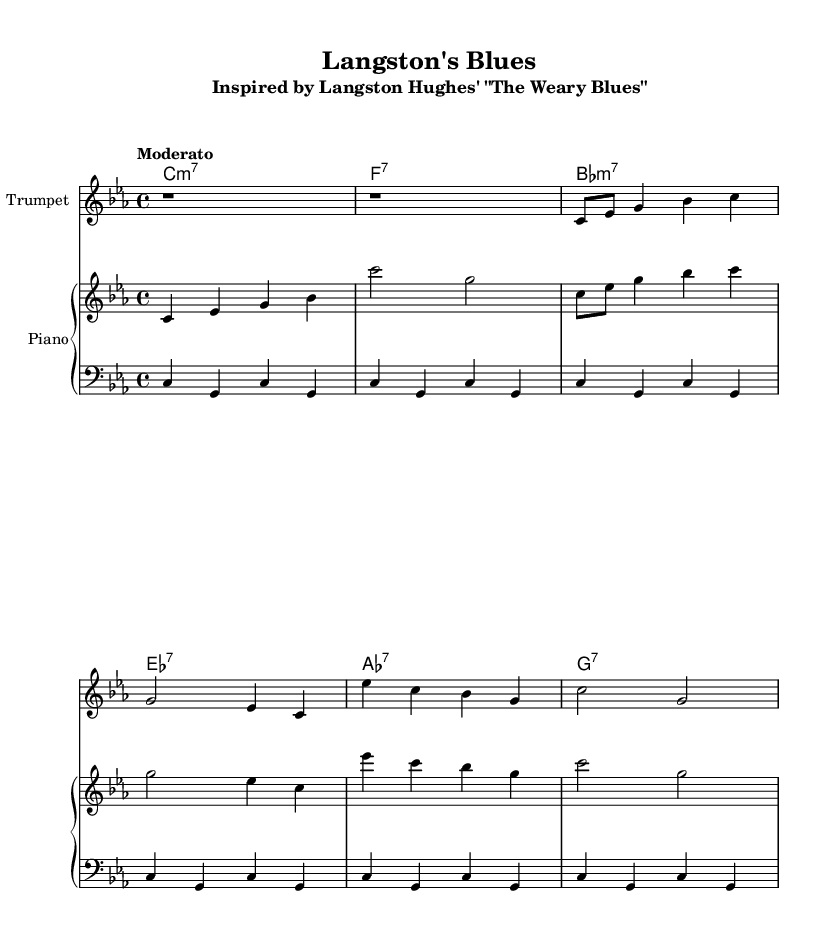What is the key signature of this music? The key signature is C minor, which has three flats: B flat, E flat, and A flat. This can be deduced from the initial positioning of the flat signs in the key signature section, indicating the use of C minor throughout the piece.
Answer: C minor What is the time signature of the piece? The time signature is 4/4, which indicates that there are four beats in each measure and the quarter note receives one beat. This can be found at the beginning of the sheet music, specified right after the key signature.
Answer: 4/4 What is the tempo marking for this composition? The tempo marking is Moderato, which indicates a moderate pace. This is usually indicated just above the staff, setting the desired speed for the performers.
Answer: Moderato How many measures does the trumpet part contain? There are eight measures in the trumpet part, identifiable by counting the groups of four beats indicated in the music. Each measure is separated by vertical bar lines.
Answer: Eight What is the first chord written in the chord progression? The first chord is C minor seventh (C minor 7), which is specified in the chord names section above the staffs. The chord is represented with its root note followed by "m7," indicating its minor seventh quality.
Answer: C minor 7 Which poetic author inspired this piece? The piece is inspired by Langston Hughes, who is renowned for his poetry. The title of the composition indicates this inspiration through a direct reference to Hughes' poem "The Weary Blues."
Answer: Langston Hughes What type of ensemble is indicated in the sheet music? The ensemble consists of a trumpet, piano, and bass, forming a classic jazz trio setup. This can be determined by the instruments listed at the start of each respective staff in the score.
Answer: Jazz trio 